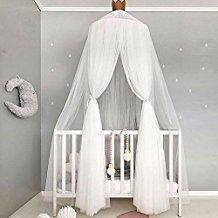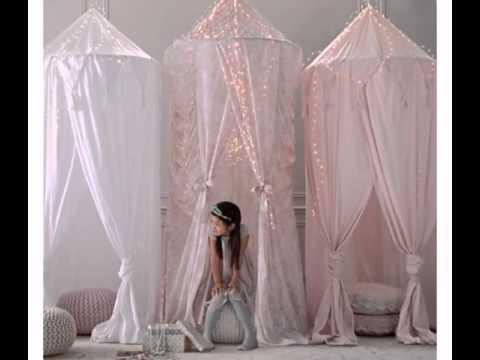The first image is the image on the left, the second image is the image on the right. Considering the images on both sides, is "There is exactly one crib with netting above it." valid? Answer yes or no. Yes. 